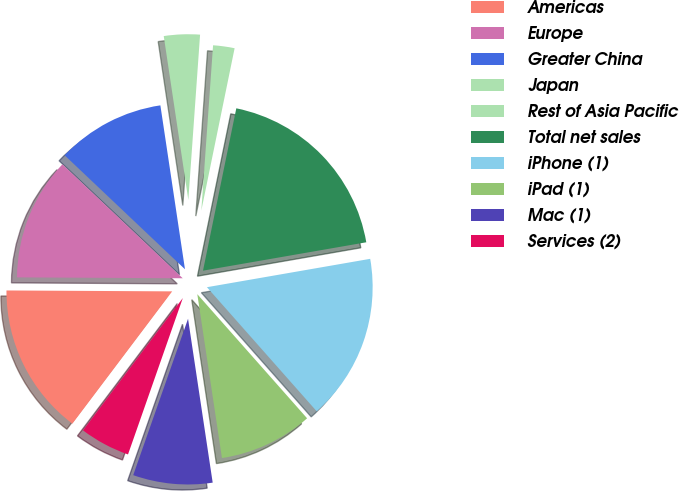Convert chart to OTSL. <chart><loc_0><loc_0><loc_500><loc_500><pie_chart><fcel>Americas<fcel>Europe<fcel>Greater China<fcel>Japan<fcel>Rest of Asia Pacific<fcel>Total net sales<fcel>iPhone (1)<fcel>iPad (1)<fcel>Mac (1)<fcel>Services (2)<nl><fcel>14.8%<fcel>11.98%<fcel>10.56%<fcel>3.5%<fcel>2.09%<fcel>19.04%<fcel>16.21%<fcel>9.15%<fcel>7.74%<fcel>4.92%<nl></chart> 